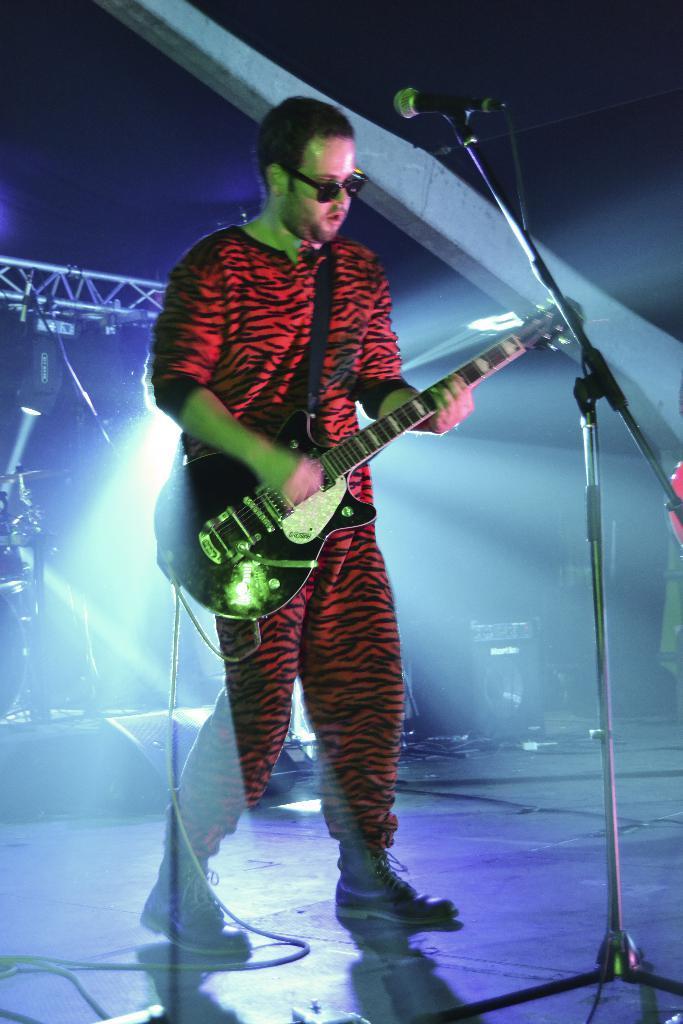Could you give a brief overview of what you see in this image? In the center we can see one man holding guitar. In front of him we can see microphone. And back we can see some musical instruments. 